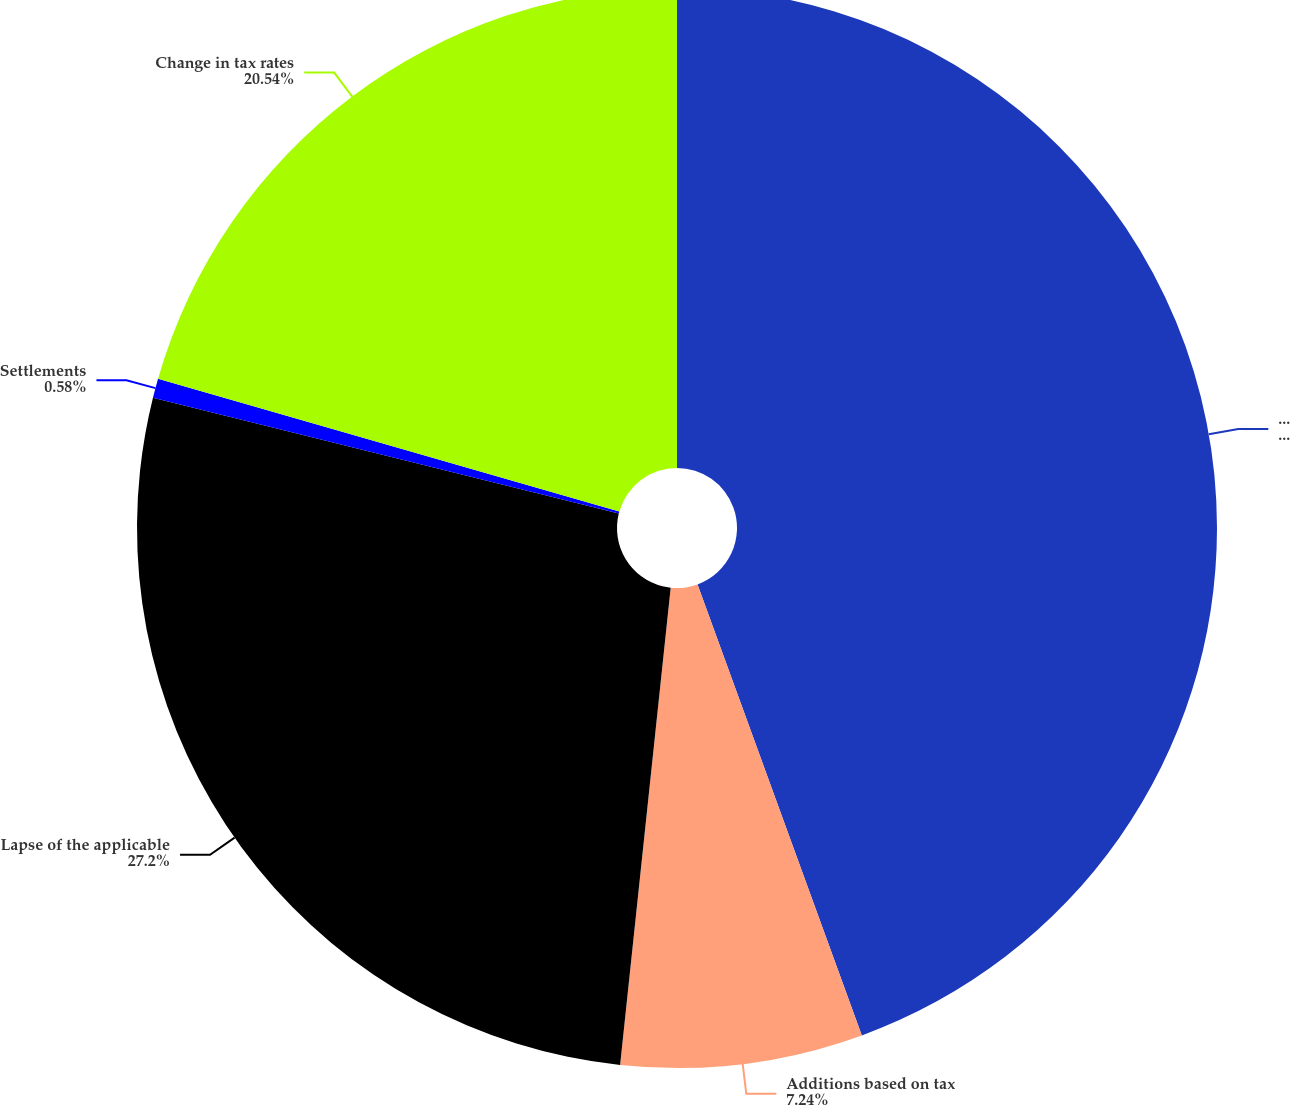<chart> <loc_0><loc_0><loc_500><loc_500><pie_chart><fcel>Unrecognized tax benefits at<fcel>Additions based on tax<fcel>Lapse of the applicable<fcel>Settlements<fcel>Change in tax rates<nl><fcel>44.44%<fcel>7.24%<fcel>27.2%<fcel>0.58%<fcel>20.54%<nl></chart> 